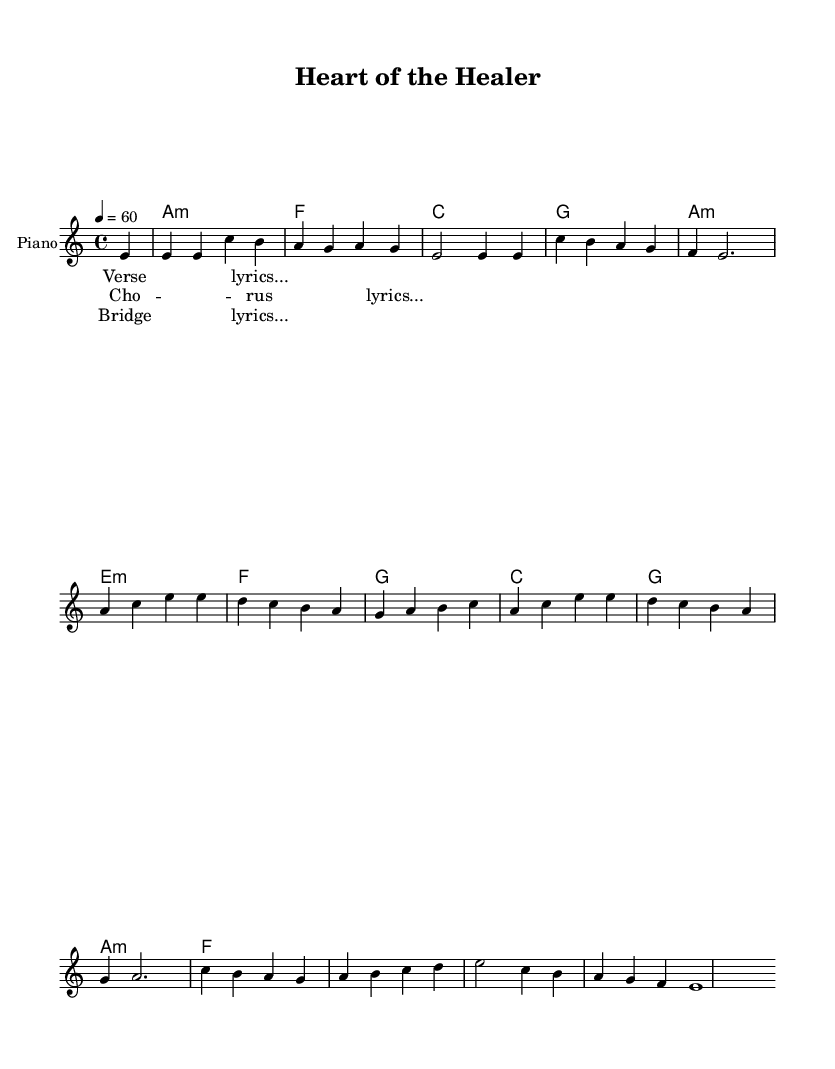What is the key signature of this music? The key signature is A minor, which contains no sharps and only one flat (the C). This can be determined by looking at the key signature indicated at the beginning of the sheet music.
Answer: A minor What is the time signature used in this piece? The time signature indicated at the beginning is 4/4, meaning there are four beats in each measure, and a quarter note gets one beat. This is observed in the notation directly provided in the sheet music.
Answer: 4/4 What is the tempo marking for this music? The tempo marking is 60 beats per minute, which is indicated at the top of the sheet music with "4 = 60". The number represents the specific tempo setting, denoting the speed of the piece.
Answer: 60 How many measures are there in the melody? There are 8 measures in the melody, as counted by the number of vertical bars in the melody line. A measure is typically represented by a vertical line in sheet music.
Answer: 8 What chords are used in the harmonies? The chords used are A minor, F, C, G, E minor. These can be identified by the chord names written above the staff during the harmonic progression shown in the sheet music.
Answer: A minor, F, C, G, E minor What is the structure of the music? The structure includes verses, a chorus, and a bridge, indicated by the specific labeling of the lyrics and their arrangement within the piece. This traditional structure is typical in Rhythm and Blues, allowing for emotional expression and storytelling.
Answer: Verse, chorus, bridge 